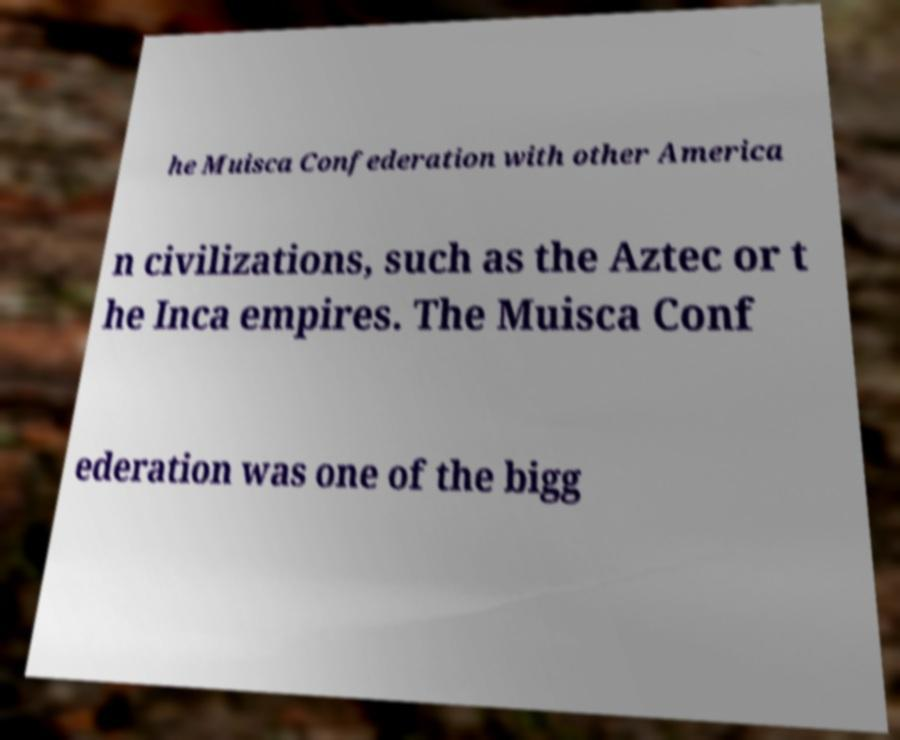Could you assist in decoding the text presented in this image and type it out clearly? he Muisca Confederation with other America n civilizations, such as the Aztec or t he Inca empires. The Muisca Conf ederation was one of the bigg 